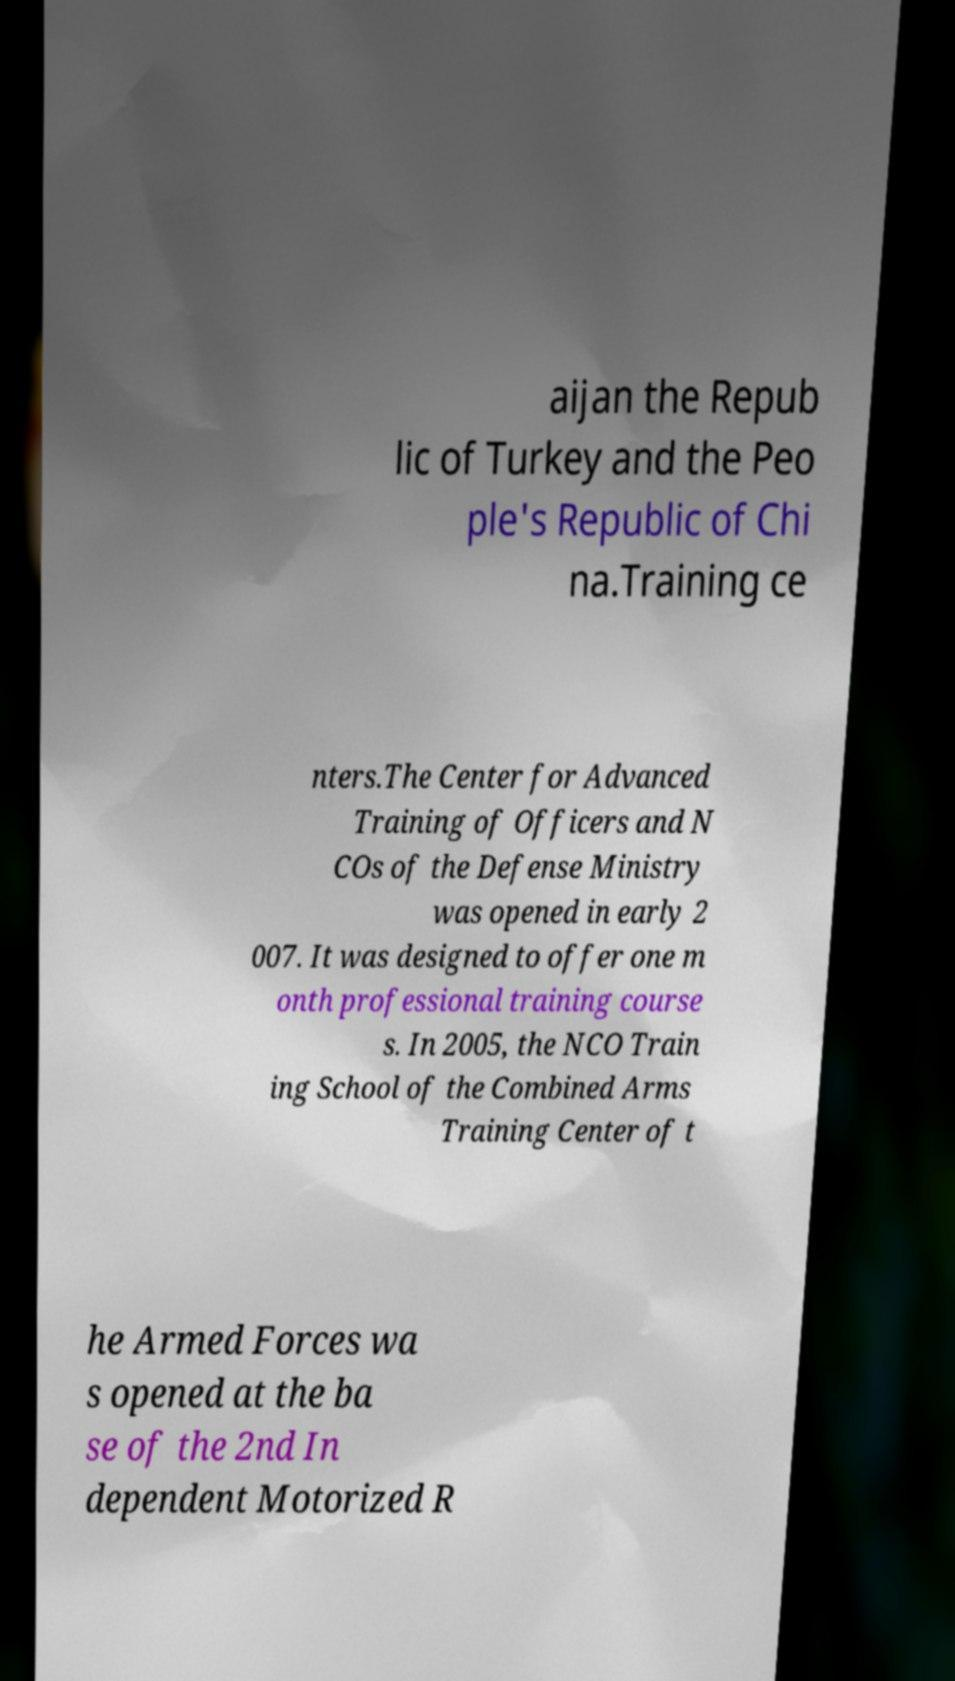What messages or text are displayed in this image? I need them in a readable, typed format. aijan the Repub lic of Turkey and the Peo ple's Republic of Chi na.Training ce nters.The Center for Advanced Training of Officers and N COs of the Defense Ministry was opened in early 2 007. It was designed to offer one m onth professional training course s. In 2005, the NCO Train ing School of the Combined Arms Training Center of t he Armed Forces wa s opened at the ba se of the 2nd In dependent Motorized R 